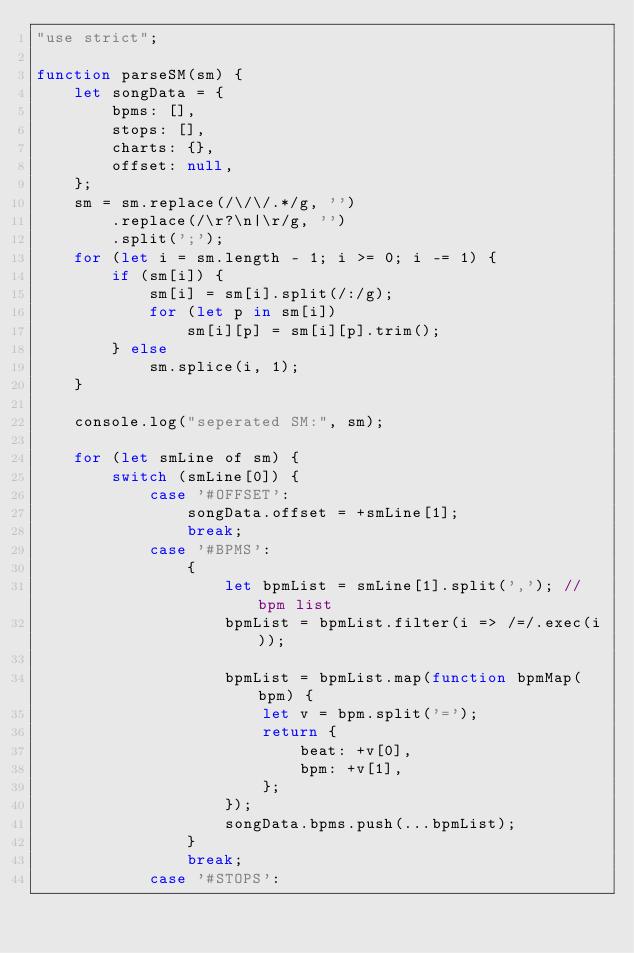<code> <loc_0><loc_0><loc_500><loc_500><_JavaScript_>"use strict";

function parseSM(sm) {
	let songData = {
		bpms: [],
		stops: [],
		charts: {},
		offset: null,
	};
	sm = sm.replace(/\/\/.*/g, '')
		.replace(/\r?\n|\r/g, '')
		.split(';');
	for (let i = sm.length - 1; i >= 0; i -= 1) {
		if (sm[i]) {
			sm[i] = sm[i].split(/:/g);
			for (let p in sm[i])
				sm[i][p] = sm[i][p].trim();
		} else
			sm.splice(i, 1);
	}

	console.log("seperated SM:", sm);

	for (let smLine of sm) {
		switch (smLine[0]) {
			case '#OFFSET':
				songData.offset = +smLine[1];
				break;
			case '#BPMS':
				{
					let bpmList = smLine[1].split(','); // bpm list
					bpmList = bpmList.filter(i => /=/.exec(i));

					bpmList = bpmList.map(function bpmMap(bpm) {
						let v = bpm.split('=');
						return {
							beat: +v[0],
							bpm: +v[1],
						};
					});
					songData.bpms.push(...bpmList);
				}
				break;
			case '#STOPS':</code> 